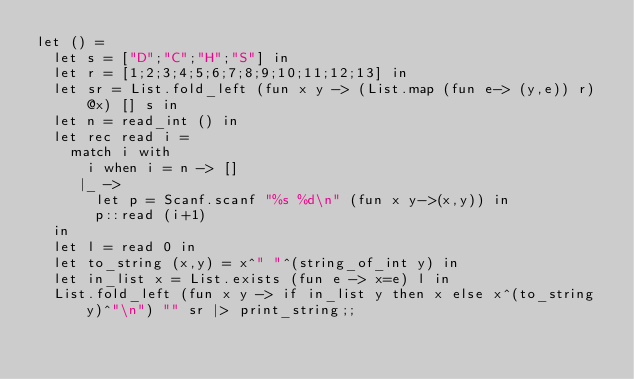<code> <loc_0><loc_0><loc_500><loc_500><_OCaml_>let () =
  let s = ["D";"C";"H";"S"] in
  let r = [1;2;3;4;5;6;7;8;9;10;11;12;13] in
  let sr = List.fold_left (fun x y -> (List.map (fun e-> (y,e)) r)@x) [] s in
  let n = read_int () in
  let rec read i =
    match i with
      i when i = n -> []
     |_ ->
       let p = Scanf.scanf "%s %d\n" (fun x y->(x,y)) in
       p::read (i+1)
  in
  let l = read 0 in
  let to_string (x,y) = x^" "^(string_of_int y) in
  let in_list x = List.exists (fun e -> x=e) l in
  List.fold_left (fun x y -> if in_list y then x else x^(to_string y)^"\n") "" sr |> print_string;;</code> 